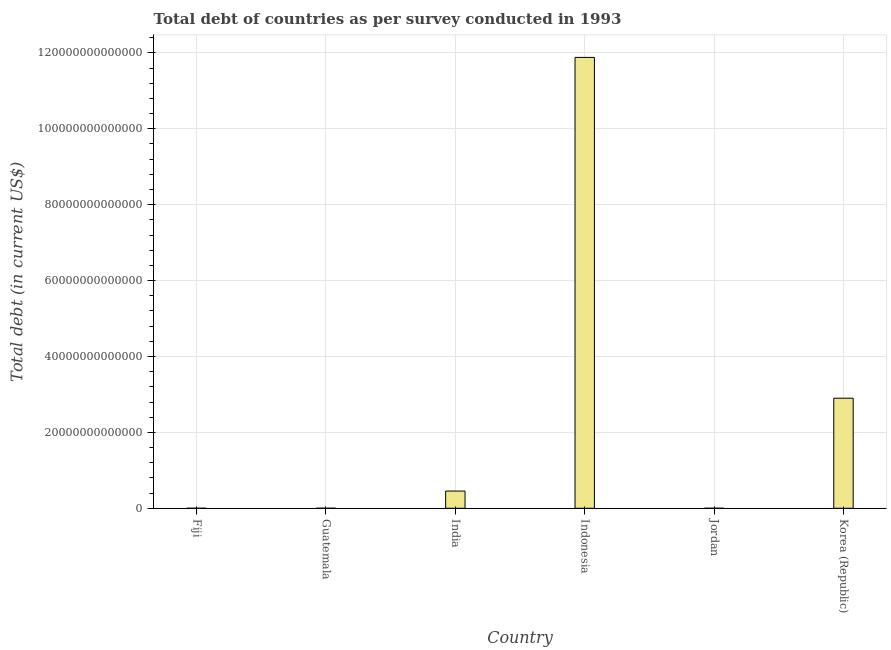Does the graph contain any zero values?
Give a very brief answer. No. Does the graph contain grids?
Provide a short and direct response. Yes. What is the title of the graph?
Give a very brief answer. Total debt of countries as per survey conducted in 1993. What is the label or title of the X-axis?
Make the answer very short. Country. What is the label or title of the Y-axis?
Provide a short and direct response. Total debt (in current US$). What is the total debt in Jordan?
Your answer should be very brief. 4.88e+09. Across all countries, what is the maximum total debt?
Your answer should be very brief. 1.19e+14. Across all countries, what is the minimum total debt?
Provide a short and direct response. 9.22e+08. In which country was the total debt maximum?
Your answer should be very brief. Indonesia. In which country was the total debt minimum?
Offer a terse response. Fiji. What is the sum of the total debt?
Keep it short and to the point. 1.52e+14. What is the difference between the total debt in Fiji and Indonesia?
Your answer should be compact. -1.19e+14. What is the average total debt per country?
Give a very brief answer. 2.54e+13. What is the median total debt?
Offer a very short reply. 2.27e+12. In how many countries, is the total debt greater than 4000000000000 US$?
Your answer should be very brief. 3. What is the ratio of the total debt in India to that in Jordan?
Your answer should be very brief. 929.28. Is the total debt in Guatemala less than that in Korea (Republic)?
Provide a succinct answer. Yes. What is the difference between the highest and the second highest total debt?
Your answer should be compact. 8.98e+13. What is the difference between the highest and the lowest total debt?
Provide a short and direct response. 1.19e+14. In how many countries, is the total debt greater than the average total debt taken over all countries?
Offer a terse response. 2. How many countries are there in the graph?
Your response must be concise. 6. What is the difference between two consecutive major ticks on the Y-axis?
Offer a very short reply. 2.00e+13. Are the values on the major ticks of Y-axis written in scientific E-notation?
Your answer should be compact. No. What is the Total debt (in current US$) of Fiji?
Your response must be concise. 9.22e+08. What is the Total debt (in current US$) in Guatemala?
Ensure brevity in your answer.  8.75e+09. What is the Total debt (in current US$) of India?
Offer a very short reply. 4.53e+12. What is the Total debt (in current US$) of Indonesia?
Provide a short and direct response. 1.19e+14. What is the Total debt (in current US$) of Jordan?
Offer a terse response. 4.88e+09. What is the Total debt (in current US$) of Korea (Republic)?
Your answer should be compact. 2.90e+13. What is the difference between the Total debt (in current US$) in Fiji and Guatemala?
Offer a very short reply. -7.83e+09. What is the difference between the Total debt (in current US$) in Fiji and India?
Ensure brevity in your answer.  -4.53e+12. What is the difference between the Total debt (in current US$) in Fiji and Indonesia?
Make the answer very short. -1.19e+14. What is the difference between the Total debt (in current US$) in Fiji and Jordan?
Make the answer very short. -3.96e+09. What is the difference between the Total debt (in current US$) in Fiji and Korea (Republic)?
Offer a terse response. -2.90e+13. What is the difference between the Total debt (in current US$) in Guatemala and India?
Provide a succinct answer. -4.53e+12. What is the difference between the Total debt (in current US$) in Guatemala and Indonesia?
Provide a succinct answer. -1.19e+14. What is the difference between the Total debt (in current US$) in Guatemala and Jordan?
Your answer should be compact. 3.87e+09. What is the difference between the Total debt (in current US$) in Guatemala and Korea (Republic)?
Keep it short and to the point. -2.90e+13. What is the difference between the Total debt (in current US$) in India and Indonesia?
Ensure brevity in your answer.  -1.14e+14. What is the difference between the Total debt (in current US$) in India and Jordan?
Keep it short and to the point. 4.53e+12. What is the difference between the Total debt (in current US$) in India and Korea (Republic)?
Ensure brevity in your answer.  -2.45e+13. What is the difference between the Total debt (in current US$) in Indonesia and Jordan?
Give a very brief answer. 1.19e+14. What is the difference between the Total debt (in current US$) in Indonesia and Korea (Republic)?
Ensure brevity in your answer.  8.98e+13. What is the difference between the Total debt (in current US$) in Jordan and Korea (Republic)?
Make the answer very short. -2.90e+13. What is the ratio of the Total debt (in current US$) in Fiji to that in Guatemala?
Your answer should be very brief. 0.1. What is the ratio of the Total debt (in current US$) in Fiji to that in India?
Make the answer very short. 0. What is the ratio of the Total debt (in current US$) in Fiji to that in Jordan?
Give a very brief answer. 0.19. What is the ratio of the Total debt (in current US$) in Fiji to that in Korea (Republic)?
Give a very brief answer. 0. What is the ratio of the Total debt (in current US$) in Guatemala to that in India?
Provide a succinct answer. 0. What is the ratio of the Total debt (in current US$) in Guatemala to that in Indonesia?
Give a very brief answer. 0. What is the ratio of the Total debt (in current US$) in Guatemala to that in Jordan?
Make the answer very short. 1.79. What is the ratio of the Total debt (in current US$) in India to that in Indonesia?
Provide a succinct answer. 0.04. What is the ratio of the Total debt (in current US$) in India to that in Jordan?
Ensure brevity in your answer.  929.28. What is the ratio of the Total debt (in current US$) in India to that in Korea (Republic)?
Your response must be concise. 0.16. What is the ratio of the Total debt (in current US$) in Indonesia to that in Jordan?
Keep it short and to the point. 2.43e+04. What is the ratio of the Total debt (in current US$) in Indonesia to that in Korea (Republic)?
Ensure brevity in your answer.  4.1. What is the ratio of the Total debt (in current US$) in Jordan to that in Korea (Republic)?
Offer a terse response. 0. 